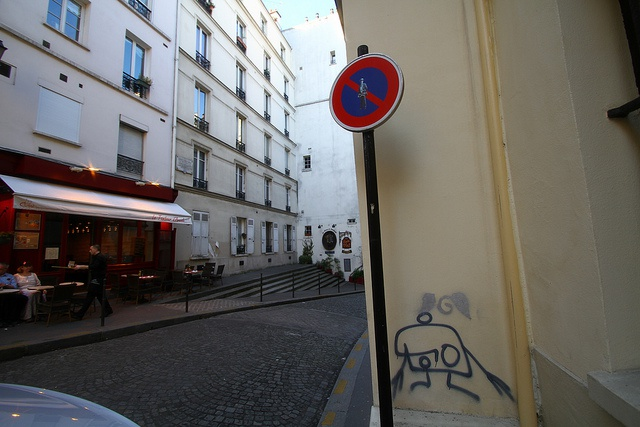Describe the objects in this image and their specific colors. I can see car in gray, darkblue, and black tones, people in gray, black, maroon, and brown tones, chair in gray, black, brown, and maroon tones, people in gray, black, and maroon tones, and people in gray, black, darkblue, navy, and maroon tones in this image. 